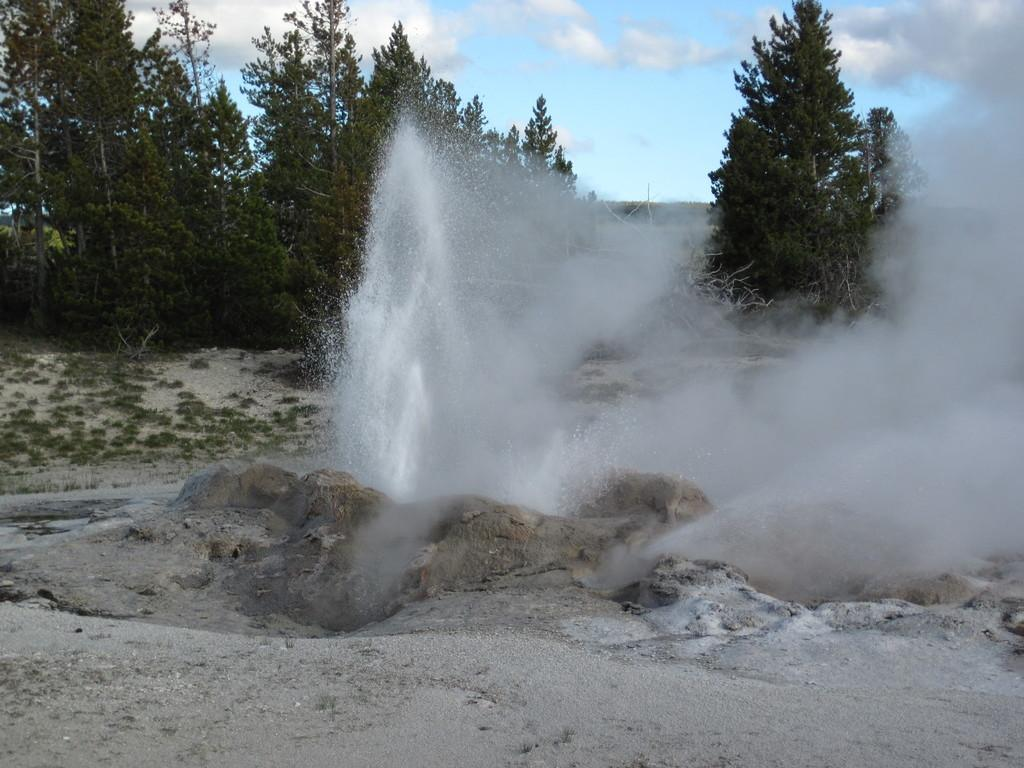What type of natural elements can be seen on the ground in the image? There are stones on the ground in the image. What is present in the air in the image? There is water visible in the air. What type of vegetation is in the background of the image? There are trees in the background of the image. What type of ground cover is visible in the background of the image? There is grass on the ground in the background of the image. What is visible at the top of the image? The sky is visible at the top of the image. How many fingers can be seen pointing at the cherry in the image? There is no cherry or fingers present in the image. What type of copy machine is visible in the background of the image? There is no copy machine present in the image. 